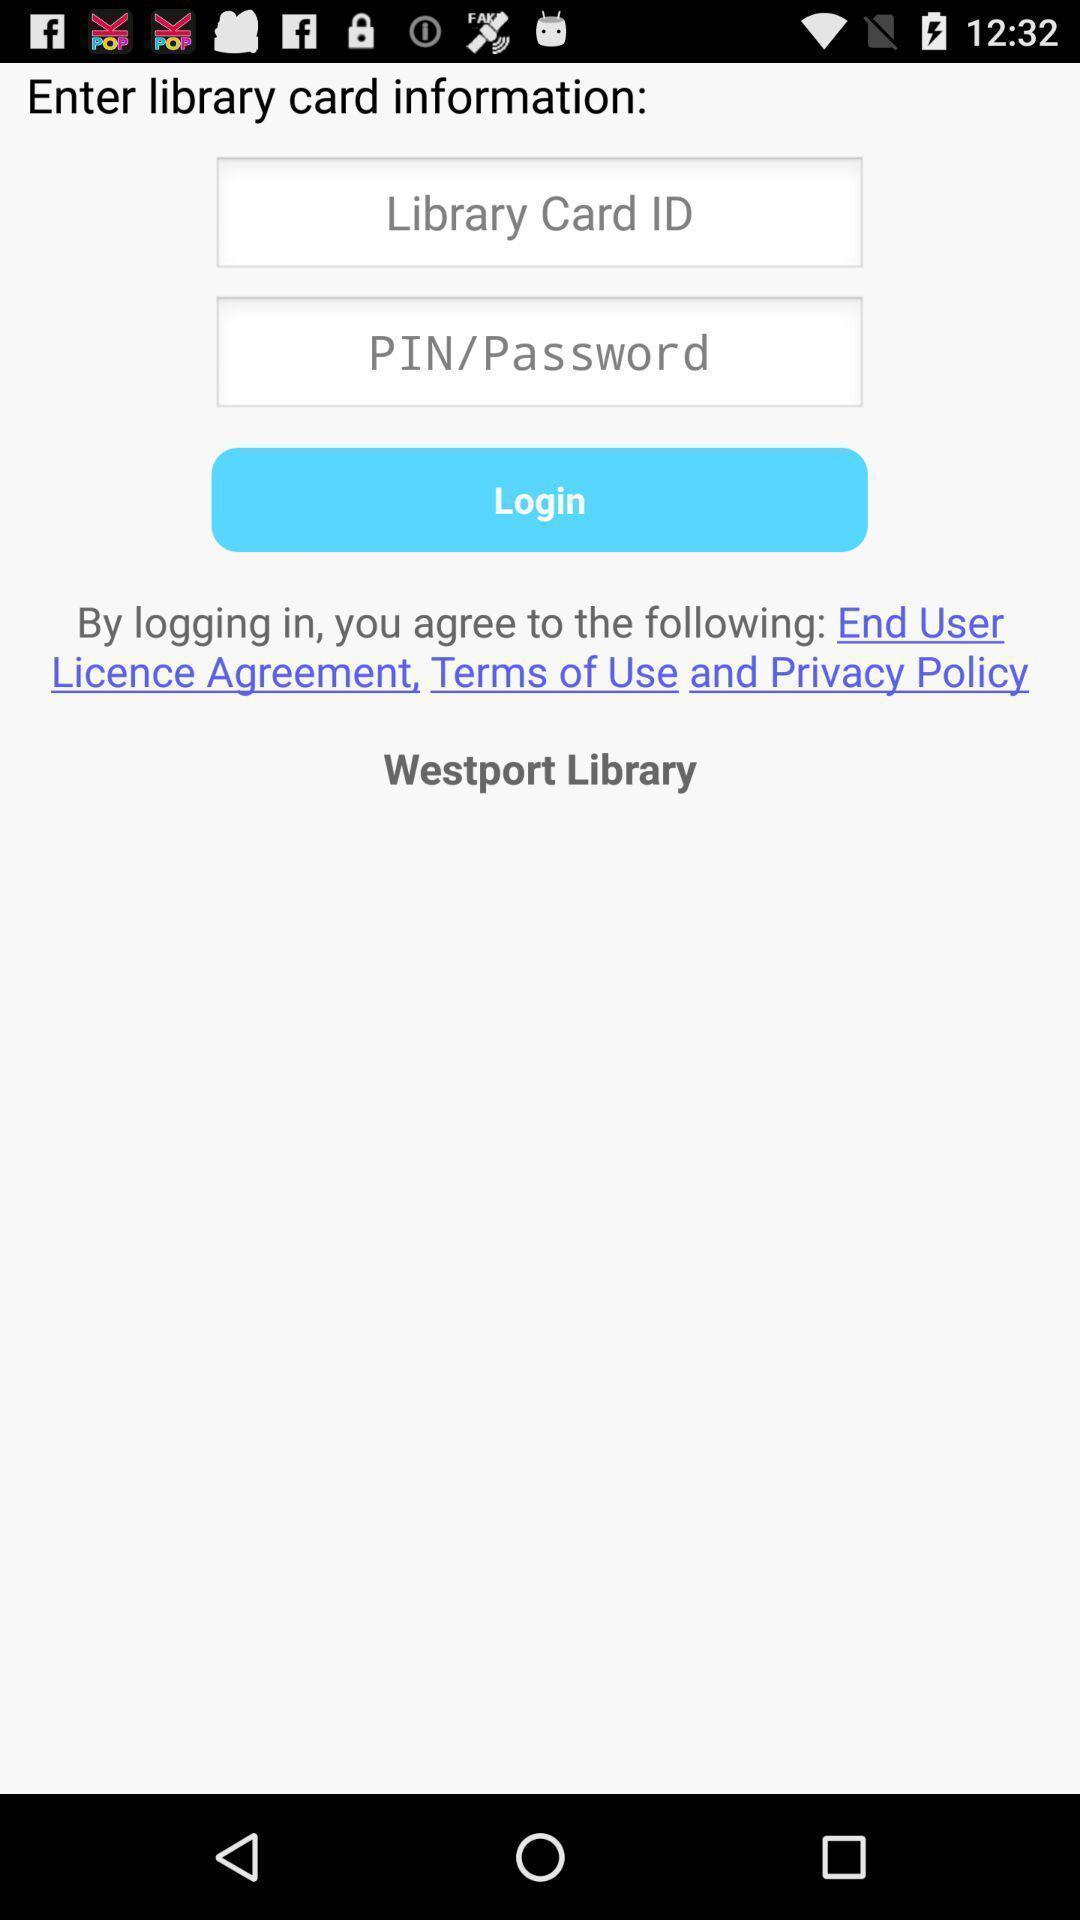Describe the visual elements of this screenshot. Login page to enter card information in library app. 